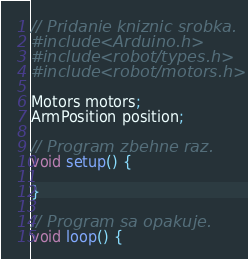Convert code to text. <code><loc_0><loc_0><loc_500><loc_500><_C++_>// Pridanie kniznic srobka.
#include <Arduino.h>
#include <robot/types.h>
#include <robot/motors.h>

Motors motors;
ArmPosition position;

// Program zbehne raz.
void setup() {
    
}

// Program sa opakuje.
void loop() {</code> 